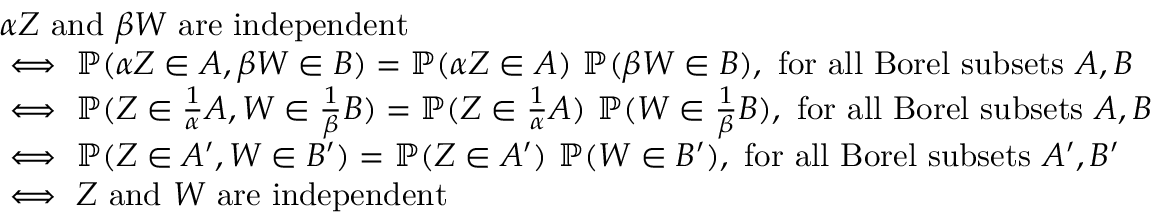<formula> <loc_0><loc_0><loc_500><loc_500>\begin{array} { r l } & { \alpha Z a n d \beta W a r e i n d e p e n d e n t } \\ & { \iff \mathbb { P } ( \alpha Z \in A , \beta W \in B ) = \mathbb { P } ( \alpha Z \in A ) \ \mathbb { P } ( \beta W \in B ) , f o r a l l B o r e l s u b s e t s A , B } \\ & { \iff \mathbb { P } ( Z \in \frac { 1 } { \alpha } A , W \in \frac { 1 } { \beta } B ) = \mathbb { P } ( Z \in \frac { 1 } { \alpha } A ) \ \mathbb { P } ( W \in \frac { 1 } { \beta } B ) , f o r a l l B o r e l s u b s e t s A , B } \\ & { \iff \mathbb { P } ( Z \in A ^ { \prime } , W \in B ^ { \prime } ) = \mathbb { P } ( Z \in A ^ { \prime } ) \ \mathbb { P } ( W \in B ^ { \prime } ) , f o r a l l B o r e l s u b s e t s A ^ { \prime } , B ^ { \prime } } \\ & { \iff Z a n d W a r e i n d e p e n d e n t } \end{array}</formula> 